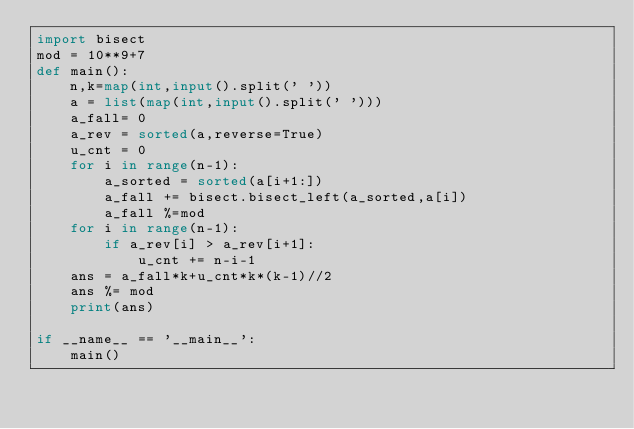Convert code to text. <code><loc_0><loc_0><loc_500><loc_500><_Python_>import bisect
mod = 10**9+7
def main():
    n,k=map(int,input().split(' '))
    a = list(map(int,input().split(' ')))
    a_fall= 0
    a_rev = sorted(a,reverse=True)
    u_cnt = 0
    for i in range(n-1):
        a_sorted = sorted(a[i+1:])
        a_fall += bisect.bisect_left(a_sorted,a[i])
        a_fall %=mod
    for i in range(n-1):
        if a_rev[i] > a_rev[i+1]:
            u_cnt += n-i-1
    ans = a_fall*k+u_cnt*k*(k-1)//2
    ans %= mod
    print(ans)

if __name__ == '__main__':
    main()</code> 